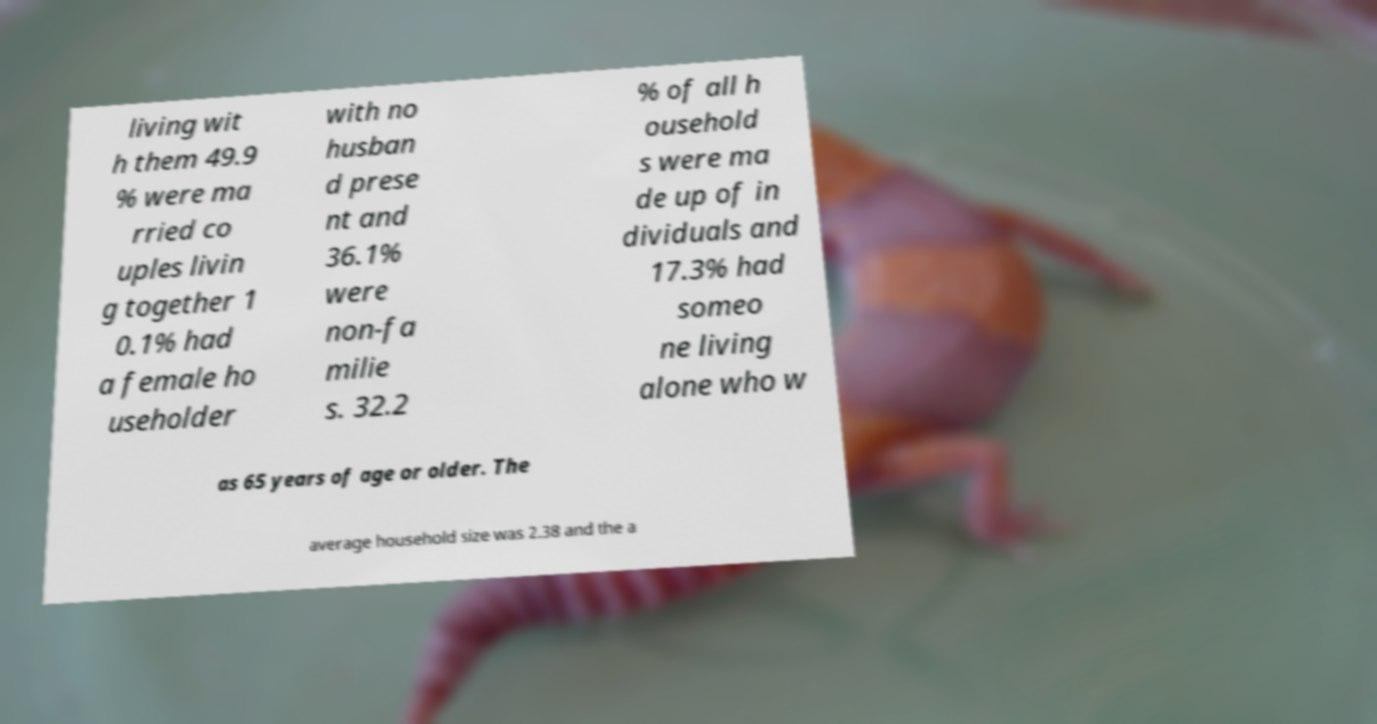I need the written content from this picture converted into text. Can you do that? living wit h them 49.9 % were ma rried co uples livin g together 1 0.1% had a female ho useholder with no husban d prese nt and 36.1% were non-fa milie s. 32.2 % of all h ousehold s were ma de up of in dividuals and 17.3% had someo ne living alone who w as 65 years of age or older. The average household size was 2.38 and the a 